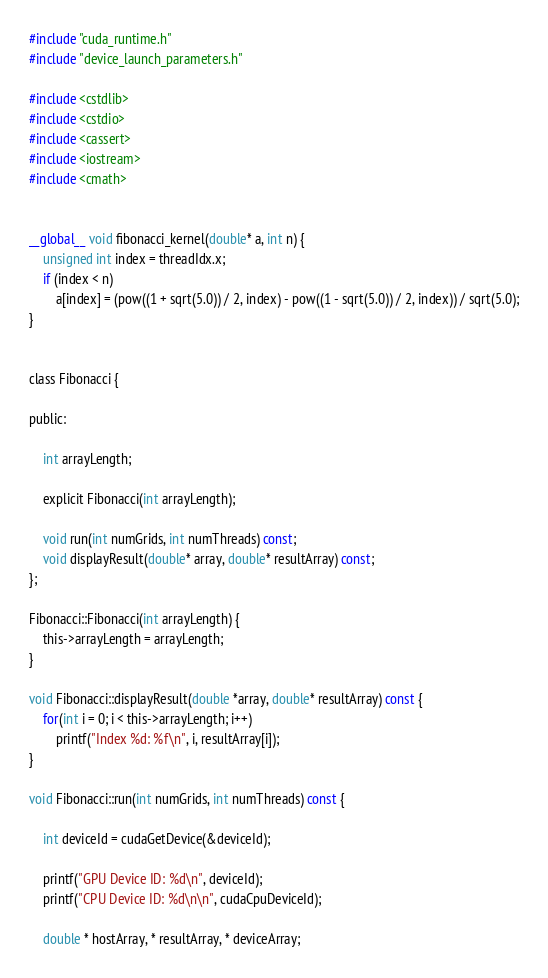<code> <loc_0><loc_0><loc_500><loc_500><_Cuda_>#include "cuda_runtime.h"
#include "device_launch_parameters.h"

#include <cstdlib>
#include <cstdio>
#include <cassert>
#include <iostream>
#include <cmath>


__global__ void fibonacci_kernel(double* a, int n) {
    unsigned int index = threadIdx.x;
    if (index < n)
        a[index] = (pow((1 + sqrt(5.0)) / 2, index) - pow((1 - sqrt(5.0)) / 2, index)) / sqrt(5.0);
}


class Fibonacci {

public:

    int arrayLength;

    explicit Fibonacci(int arrayLength);

    void run(int numGrids, int numThreads) const;
    void displayResult(double* array, double* resultArray) const;
};

Fibonacci::Fibonacci(int arrayLength) {
    this->arrayLength = arrayLength;
}

void Fibonacci::displayResult(double *array, double* resultArray) const {
    for(int i = 0; i < this->arrayLength; i++)
        printf("Index %d: %f\n", i, resultArray[i]);
}

void Fibonacci::run(int numGrids, int numThreads) const {

    int deviceId = cudaGetDevice(&deviceId);

    printf("GPU Device ID: %d\n", deviceId);
    printf("CPU Device ID: %d\n\n", cudaCpuDeviceId);

    double * hostArray, * resultArray, * deviceArray;</code> 